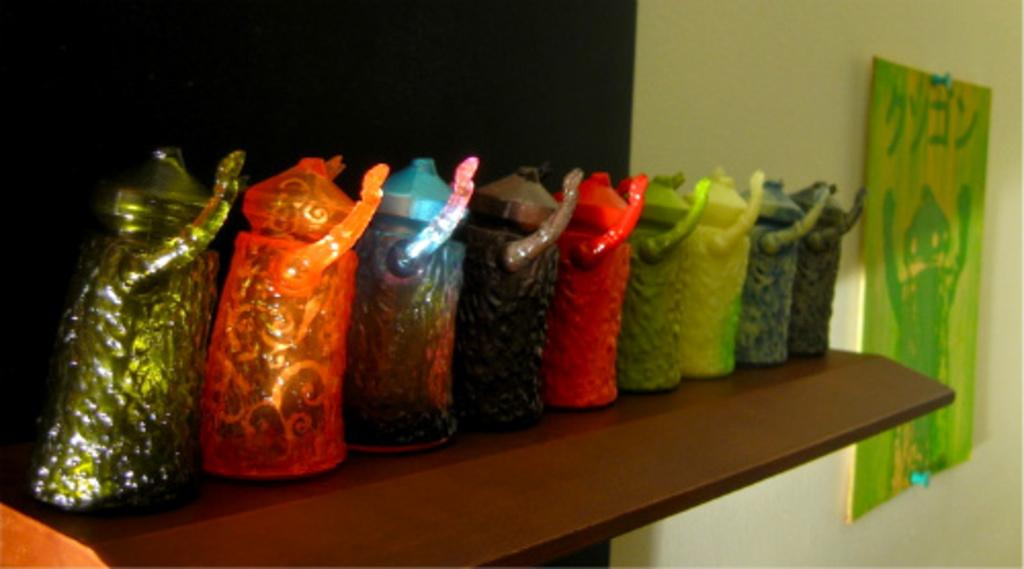What type of items can be seen on the rack in the image? There are different colored decorative items on a rack in the image. What is the color of the rack? The rack is in brown color. What is attached to the wall in the image? A frame is attached to the wall. What is the color of the wall? The wall is in black color. Can you see any sleet falling on the hill in the image? There is no hill or sleet present in the image; it features a rack with decorative items, a brown rack, a frame on a black wall. 